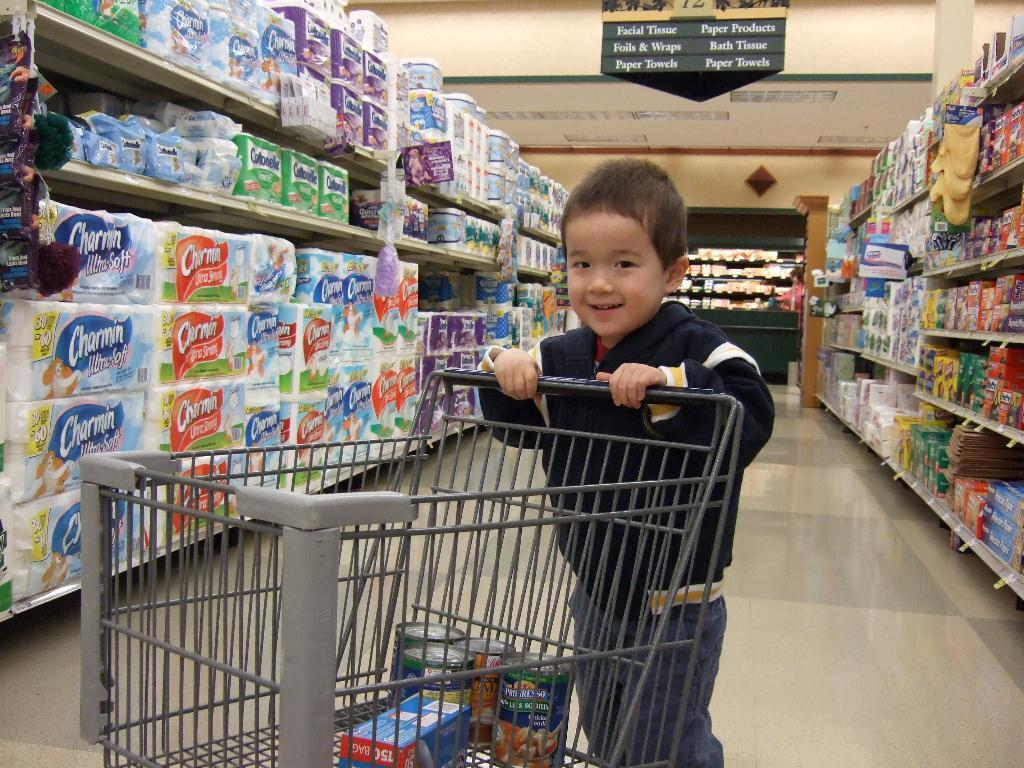<image>
Present a compact description of the photo's key features. A boy is pushing a shopping cart in a grocery isle with Charmin toilet paper. 